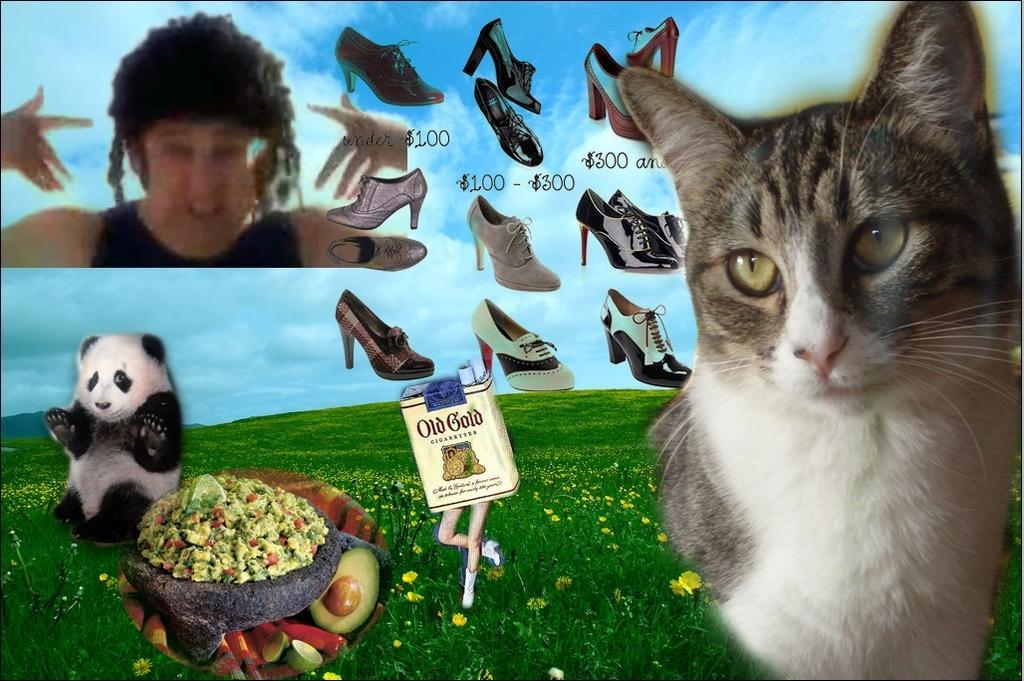How would you summarize this image in a sentence or two? This is a poster and in this poster we can see a cat, panda, cigarette box, person, food items, sandals, grass, plants with flowers and in the background we can see the sky with clouds. 